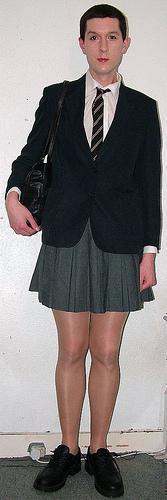How many people wearing ties are in the picture?
Give a very brief answer. 1. 